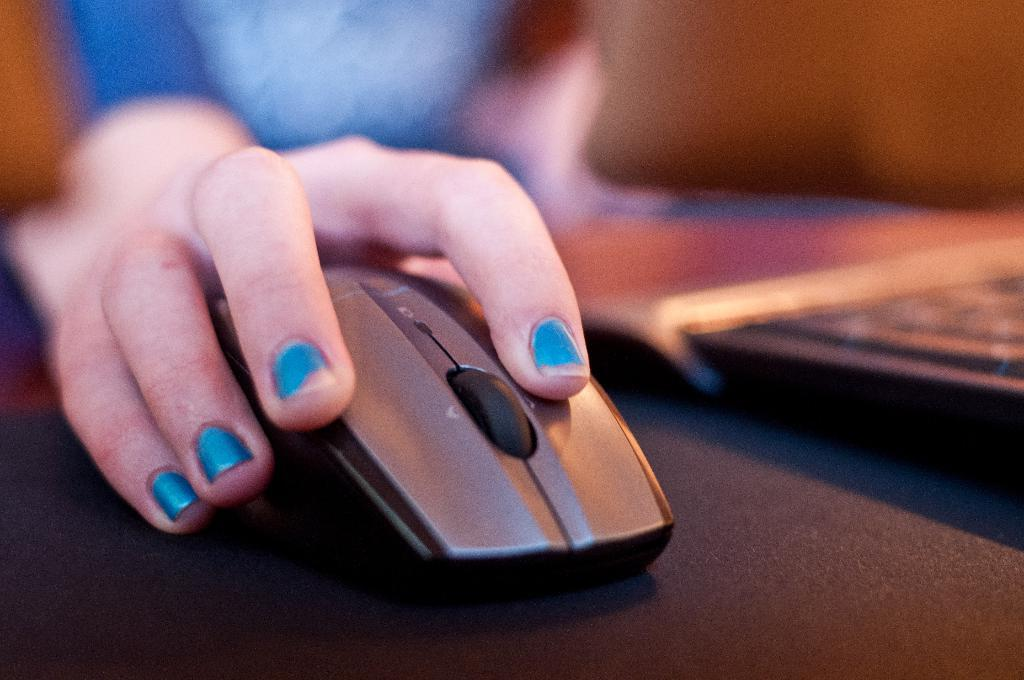What is the person's hand doing in the foreground of the image? The person's hand is on a mouse in the foreground of the image. What electronic device is visible on the right side of the image? There is a laptop on the right side of the image. What color is the surface on which the laptop is placed? The laptop is on a black surface. Can you describe the person visible at the top of the image? There is a person visible at the top of the image, but no specific details about their appearance are provided. What type of houses can be seen in the quicksand in the image? There is no quicksand or houses present in the image. What scent is emanating from the laptop in the image? There is no mention of a scent in the image, and laptops do not typically emit scents. 